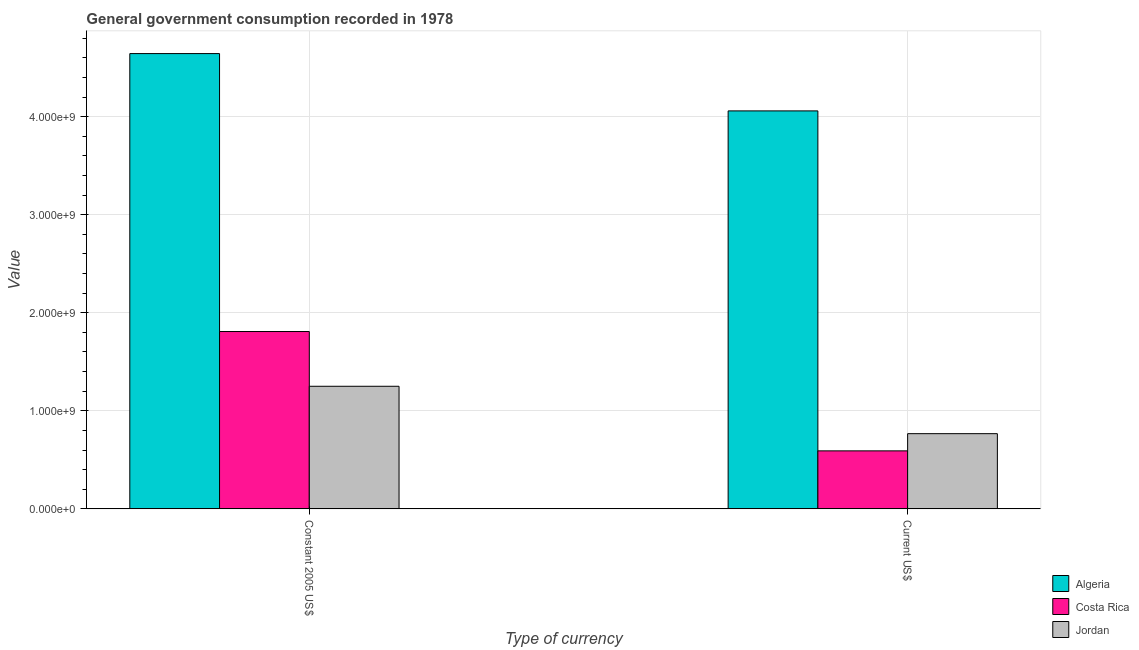How many different coloured bars are there?
Make the answer very short. 3. How many groups of bars are there?
Your answer should be compact. 2. Are the number of bars per tick equal to the number of legend labels?
Your answer should be very brief. Yes. How many bars are there on the 2nd tick from the right?
Your answer should be very brief. 3. What is the label of the 2nd group of bars from the left?
Keep it short and to the point. Current US$. What is the value consumed in constant 2005 us$ in Costa Rica?
Make the answer very short. 1.81e+09. Across all countries, what is the maximum value consumed in current us$?
Make the answer very short. 4.06e+09. Across all countries, what is the minimum value consumed in constant 2005 us$?
Provide a succinct answer. 1.25e+09. In which country was the value consumed in current us$ maximum?
Your response must be concise. Algeria. In which country was the value consumed in current us$ minimum?
Offer a terse response. Costa Rica. What is the total value consumed in constant 2005 us$ in the graph?
Make the answer very short. 7.70e+09. What is the difference between the value consumed in current us$ in Algeria and that in Jordan?
Provide a short and direct response. 3.29e+09. What is the difference between the value consumed in current us$ in Jordan and the value consumed in constant 2005 us$ in Costa Rica?
Your answer should be very brief. -1.04e+09. What is the average value consumed in constant 2005 us$ per country?
Your response must be concise. 2.57e+09. What is the difference between the value consumed in constant 2005 us$ and value consumed in current us$ in Costa Rica?
Your response must be concise. 1.22e+09. In how many countries, is the value consumed in constant 2005 us$ greater than 200000000 ?
Make the answer very short. 3. What is the ratio of the value consumed in constant 2005 us$ in Algeria to that in Jordan?
Your answer should be compact. 3.71. Is the value consumed in current us$ in Costa Rica less than that in Jordan?
Your response must be concise. Yes. What does the 1st bar from the left in Constant 2005 US$ represents?
Provide a short and direct response. Algeria. What does the 2nd bar from the right in Constant 2005 US$ represents?
Provide a succinct answer. Costa Rica. Are all the bars in the graph horizontal?
Give a very brief answer. No. Are the values on the major ticks of Y-axis written in scientific E-notation?
Keep it short and to the point. Yes. Does the graph contain any zero values?
Ensure brevity in your answer.  No. Does the graph contain grids?
Your response must be concise. Yes. How many legend labels are there?
Offer a terse response. 3. How are the legend labels stacked?
Your response must be concise. Vertical. What is the title of the graph?
Give a very brief answer. General government consumption recorded in 1978. What is the label or title of the X-axis?
Keep it short and to the point. Type of currency. What is the label or title of the Y-axis?
Give a very brief answer. Value. What is the Value in Algeria in Constant 2005 US$?
Offer a very short reply. 4.64e+09. What is the Value in Costa Rica in Constant 2005 US$?
Your answer should be very brief. 1.81e+09. What is the Value in Jordan in Constant 2005 US$?
Provide a short and direct response. 1.25e+09. What is the Value of Algeria in Current US$?
Offer a very short reply. 4.06e+09. What is the Value of Costa Rica in Current US$?
Provide a succinct answer. 5.91e+08. What is the Value of Jordan in Current US$?
Make the answer very short. 7.67e+08. Across all Type of currency, what is the maximum Value of Algeria?
Ensure brevity in your answer.  4.64e+09. Across all Type of currency, what is the maximum Value of Costa Rica?
Keep it short and to the point. 1.81e+09. Across all Type of currency, what is the maximum Value of Jordan?
Offer a very short reply. 1.25e+09. Across all Type of currency, what is the minimum Value in Algeria?
Provide a succinct answer. 4.06e+09. Across all Type of currency, what is the minimum Value in Costa Rica?
Keep it short and to the point. 5.91e+08. Across all Type of currency, what is the minimum Value of Jordan?
Provide a short and direct response. 7.67e+08. What is the total Value of Algeria in the graph?
Your answer should be compact. 8.70e+09. What is the total Value in Costa Rica in the graph?
Your answer should be compact. 2.40e+09. What is the total Value in Jordan in the graph?
Give a very brief answer. 2.02e+09. What is the difference between the Value of Algeria in Constant 2005 US$ and that in Current US$?
Offer a terse response. 5.85e+08. What is the difference between the Value in Costa Rica in Constant 2005 US$ and that in Current US$?
Provide a succinct answer. 1.22e+09. What is the difference between the Value in Jordan in Constant 2005 US$ and that in Current US$?
Provide a short and direct response. 4.83e+08. What is the difference between the Value of Algeria in Constant 2005 US$ and the Value of Costa Rica in Current US$?
Ensure brevity in your answer.  4.05e+09. What is the difference between the Value of Algeria in Constant 2005 US$ and the Value of Jordan in Current US$?
Your answer should be compact. 3.88e+09. What is the difference between the Value in Costa Rica in Constant 2005 US$ and the Value in Jordan in Current US$?
Provide a succinct answer. 1.04e+09. What is the average Value of Algeria per Type of currency?
Your answer should be very brief. 4.35e+09. What is the average Value of Costa Rica per Type of currency?
Ensure brevity in your answer.  1.20e+09. What is the average Value of Jordan per Type of currency?
Give a very brief answer. 1.01e+09. What is the difference between the Value in Algeria and Value in Costa Rica in Constant 2005 US$?
Keep it short and to the point. 2.84e+09. What is the difference between the Value of Algeria and Value of Jordan in Constant 2005 US$?
Your answer should be very brief. 3.39e+09. What is the difference between the Value in Costa Rica and Value in Jordan in Constant 2005 US$?
Make the answer very short. 5.59e+08. What is the difference between the Value in Algeria and Value in Costa Rica in Current US$?
Ensure brevity in your answer.  3.47e+09. What is the difference between the Value of Algeria and Value of Jordan in Current US$?
Offer a terse response. 3.29e+09. What is the difference between the Value in Costa Rica and Value in Jordan in Current US$?
Offer a terse response. -1.76e+08. What is the ratio of the Value of Algeria in Constant 2005 US$ to that in Current US$?
Your response must be concise. 1.14. What is the ratio of the Value in Costa Rica in Constant 2005 US$ to that in Current US$?
Give a very brief answer. 3.06. What is the ratio of the Value in Jordan in Constant 2005 US$ to that in Current US$?
Offer a terse response. 1.63. What is the difference between the highest and the second highest Value in Algeria?
Your response must be concise. 5.85e+08. What is the difference between the highest and the second highest Value in Costa Rica?
Provide a short and direct response. 1.22e+09. What is the difference between the highest and the second highest Value in Jordan?
Offer a very short reply. 4.83e+08. What is the difference between the highest and the lowest Value in Algeria?
Ensure brevity in your answer.  5.85e+08. What is the difference between the highest and the lowest Value in Costa Rica?
Make the answer very short. 1.22e+09. What is the difference between the highest and the lowest Value of Jordan?
Your answer should be very brief. 4.83e+08. 